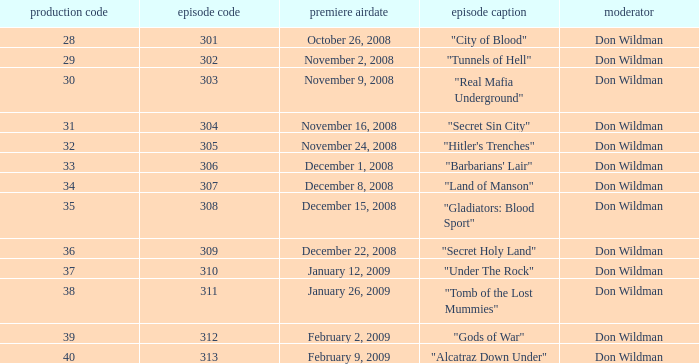What is the episode number of the episode that originally aired on January 26, 2009 and had a production number smaller than 38? 0.0. 